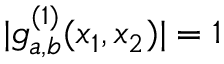Convert formula to latex. <formula><loc_0><loc_0><loc_500><loc_500>| g _ { a , b } ^ { ( 1 ) } ( x _ { 1 } , x _ { 2 } ) | = 1</formula> 